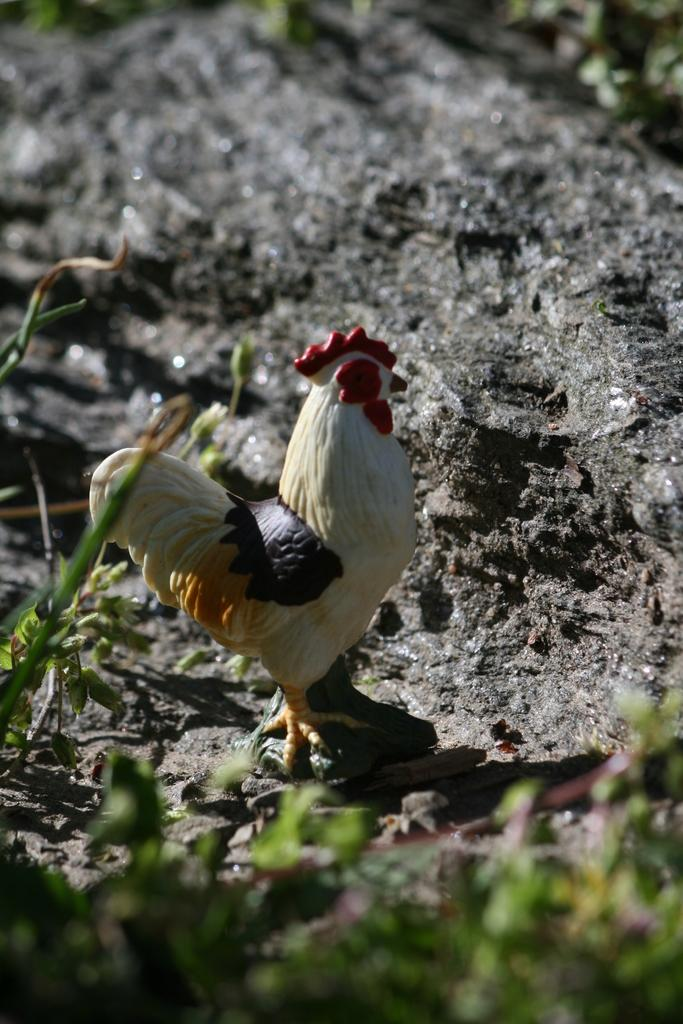What is located at the bottom of the image? There are leaves at the bottom of the image. What object can be seen behind the leaves? There is a toy cock on the ground behind the leaves. What type of expansion is happening to the toy cock in the image? There is no expansion happening to the toy cock in the image; it is a stationary object. Can you describe the flight of the toy cock in the image? The toy cock is on the ground, so it is not in flight in the image. 